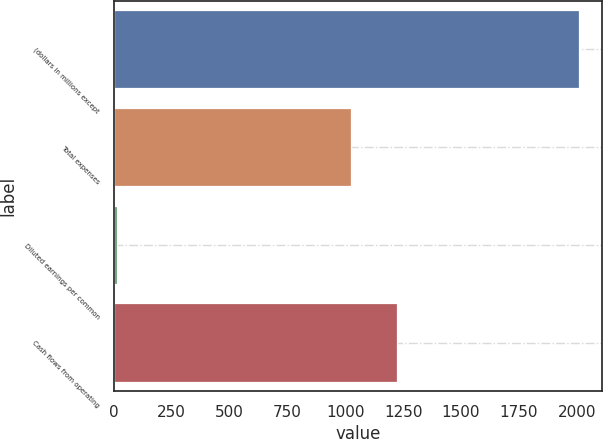Convert chart. <chart><loc_0><loc_0><loc_500><loc_500><bar_chart><fcel>(dollars in millions except<fcel>Total expenses<fcel>Diluted earnings per common<fcel>Cash flows from operating<nl><fcel>2009<fcel>1023.7<fcel>12.41<fcel>1223.36<nl></chart> 